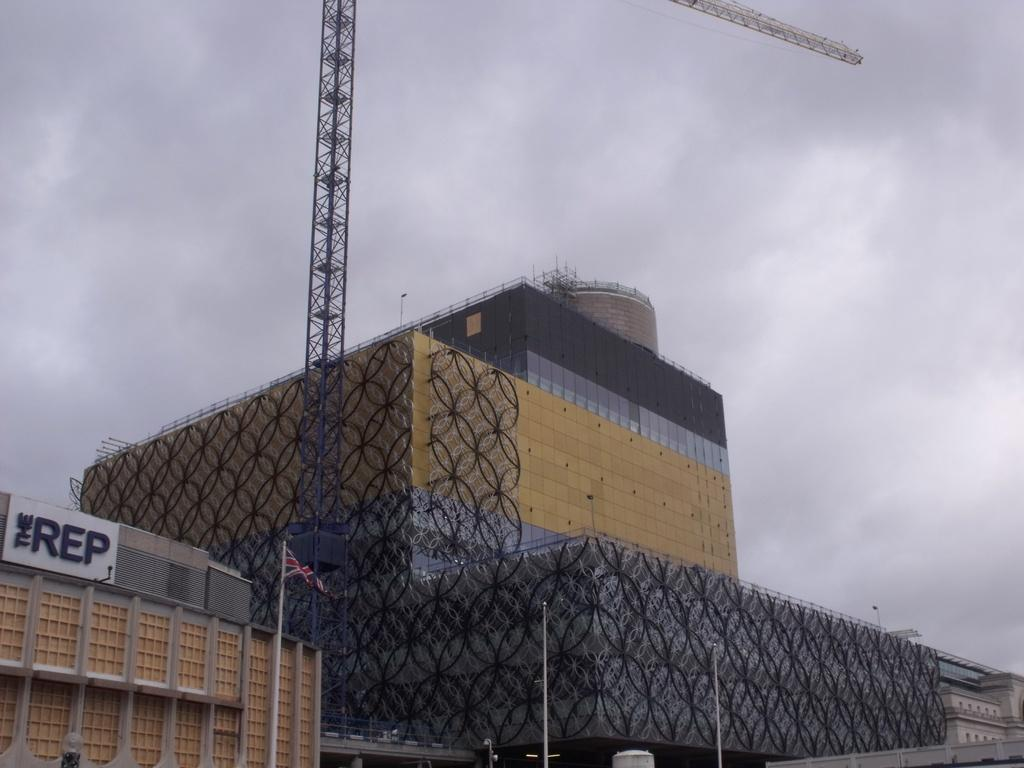What type of structures can be seen in the image? There are buildings in the image. What is written on the board that is visible in the image? There is a board with writing in the image. What can be seen flying in the image? There is a flag in the image. What are the tall, thin objects in the image? There are poles in the image. What is visible in the background of the image? The sky is visible in the background of the image. Where are the kittens playing in the image? There are no kittens present in the image. What type of wax is used to create the buildings in the image? The buildings in the image are not made of wax; they are likely made of concrete, brick, or other materials. 